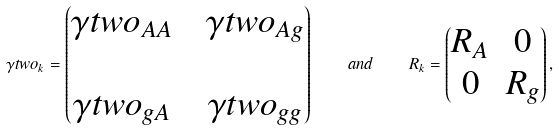<formula> <loc_0><loc_0><loc_500><loc_500>\gamma t w o _ { k } = \begin{pmatrix} \gamma t w o _ { A A } & & \gamma t w o _ { A g } \\ \\ \gamma t w o _ { g A } & & \gamma t w o _ { g g } \end{pmatrix} \quad a n d \quad R _ { k } = \begin{pmatrix} R _ { A } & 0 \\ 0 & R _ { g } \end{pmatrix} ,</formula> 